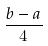<formula> <loc_0><loc_0><loc_500><loc_500>\frac { b - a } { 4 }</formula> 